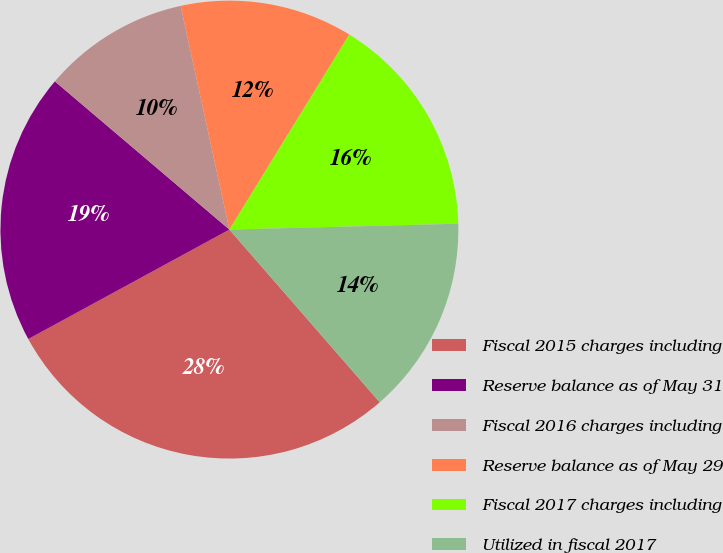<chart> <loc_0><loc_0><loc_500><loc_500><pie_chart><fcel>Fiscal 2015 charges including<fcel>Reserve balance as of May 31<fcel>Fiscal 2016 charges including<fcel>Reserve balance as of May 29<fcel>Fiscal 2017 charges including<fcel>Utilized in fiscal 2017<nl><fcel>28.47%<fcel>19.14%<fcel>10.38%<fcel>12.19%<fcel>15.82%<fcel>14.01%<nl></chart> 